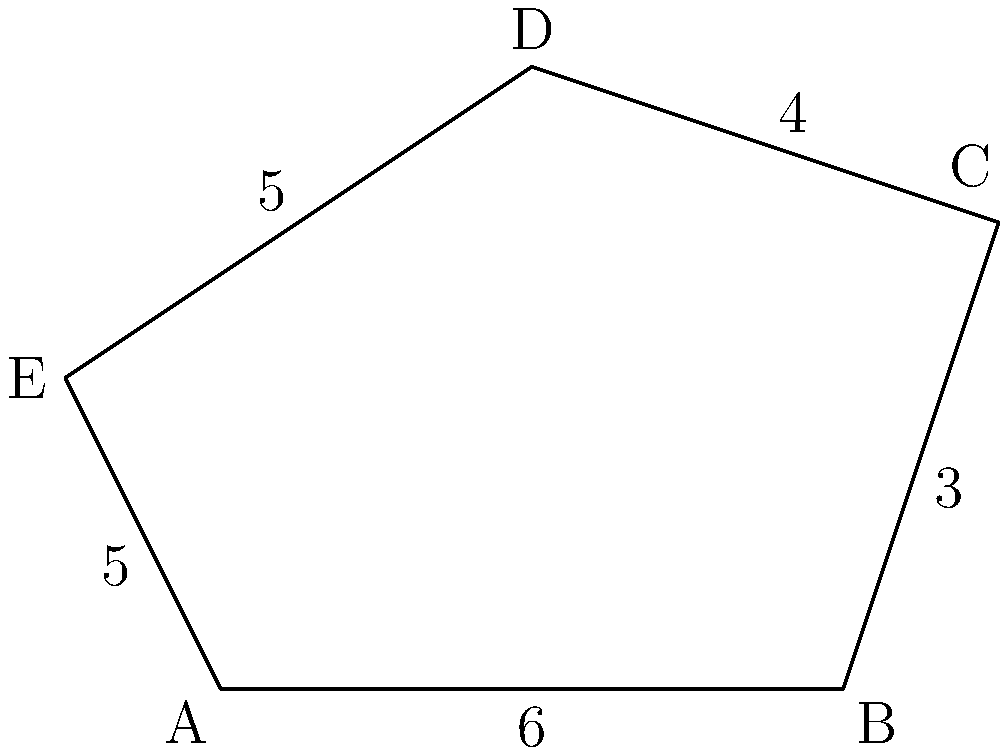Given the irregular pentagon ABCDE with side lengths as shown in the figure, calculate its perimeter. To calculate the perimeter of an irregular polygon, we need to sum up the lengths of all its sides. Let's break it down step by step:

1. Identify all the side lengths:
   - AB = 6 units
   - BC = 3 units
   - CD = 4 units
   - DE = 5 units
   - EA = 5 units

2. Add up all the side lengths:
   $$\text{Perimeter} = AB + BC + CD + DE + EA$$
   $$\text{Perimeter} = 6 + 3 + 4 + 5 + 5$$
   $$\text{Perimeter} = 23$$

Therefore, the perimeter of the irregular pentagon ABCDE is 23 units.
Answer: 23 units 